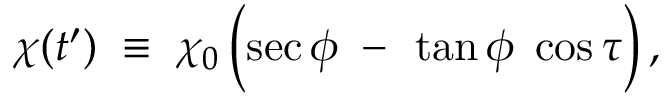<formula> <loc_0><loc_0><loc_500><loc_500>\chi ( t ^ { \prime } ) \, \equiv \, \chi _ { 0 } \left ( \sec \phi \, - { } \tan \phi \, \cos \tau \right ) ,</formula> 